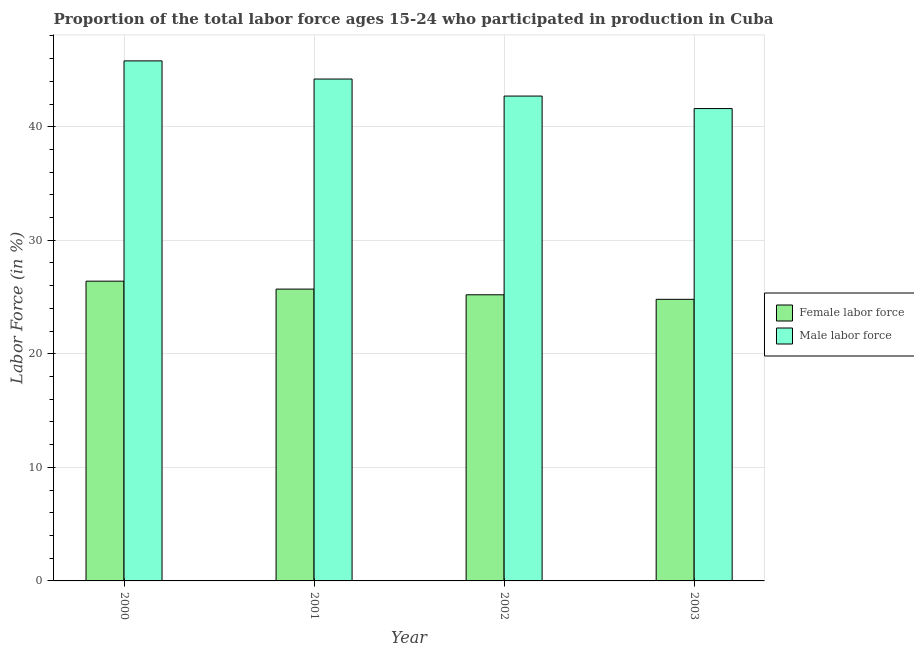How many groups of bars are there?
Keep it short and to the point. 4. Are the number of bars on each tick of the X-axis equal?
Your answer should be very brief. Yes. How many bars are there on the 3rd tick from the left?
Offer a very short reply. 2. How many bars are there on the 4th tick from the right?
Your response must be concise. 2. What is the label of the 4th group of bars from the left?
Provide a succinct answer. 2003. What is the percentage of male labour force in 2000?
Offer a terse response. 45.8. Across all years, what is the maximum percentage of male labour force?
Offer a very short reply. 45.8. Across all years, what is the minimum percentage of male labour force?
Your response must be concise. 41.6. In which year was the percentage of female labor force minimum?
Provide a short and direct response. 2003. What is the total percentage of female labor force in the graph?
Keep it short and to the point. 102.1. What is the difference between the percentage of male labour force in 2000 and that in 2003?
Offer a terse response. 4.2. What is the difference between the percentage of female labor force in 2001 and the percentage of male labour force in 2002?
Make the answer very short. 0.5. What is the average percentage of male labour force per year?
Offer a very short reply. 43.57. In the year 2000, what is the difference between the percentage of male labour force and percentage of female labor force?
Your response must be concise. 0. What is the ratio of the percentage of male labour force in 2000 to that in 2002?
Provide a succinct answer. 1.07. Is the difference between the percentage of female labor force in 2001 and 2002 greater than the difference between the percentage of male labour force in 2001 and 2002?
Provide a succinct answer. No. What is the difference between the highest and the second highest percentage of female labor force?
Your answer should be very brief. 0.7. What is the difference between the highest and the lowest percentage of female labor force?
Make the answer very short. 1.6. Is the sum of the percentage of male labour force in 2000 and 2002 greater than the maximum percentage of female labor force across all years?
Your answer should be very brief. Yes. What does the 1st bar from the left in 2003 represents?
Offer a terse response. Female labor force. What does the 2nd bar from the right in 2003 represents?
Your answer should be compact. Female labor force. How many bars are there?
Keep it short and to the point. 8. Are all the bars in the graph horizontal?
Provide a succinct answer. No. How many years are there in the graph?
Your answer should be compact. 4. What is the difference between two consecutive major ticks on the Y-axis?
Ensure brevity in your answer.  10. Does the graph contain any zero values?
Provide a succinct answer. No. Does the graph contain grids?
Ensure brevity in your answer.  Yes. What is the title of the graph?
Your answer should be compact. Proportion of the total labor force ages 15-24 who participated in production in Cuba. Does "International Tourists" appear as one of the legend labels in the graph?
Ensure brevity in your answer.  No. What is the label or title of the X-axis?
Give a very brief answer. Year. What is the label or title of the Y-axis?
Your answer should be compact. Labor Force (in %). What is the Labor Force (in %) in Female labor force in 2000?
Your answer should be compact. 26.4. What is the Labor Force (in %) in Male labor force in 2000?
Provide a short and direct response. 45.8. What is the Labor Force (in %) in Female labor force in 2001?
Make the answer very short. 25.7. What is the Labor Force (in %) in Male labor force in 2001?
Provide a succinct answer. 44.2. What is the Labor Force (in %) of Female labor force in 2002?
Ensure brevity in your answer.  25.2. What is the Labor Force (in %) of Male labor force in 2002?
Offer a terse response. 42.7. What is the Labor Force (in %) in Female labor force in 2003?
Offer a terse response. 24.8. What is the Labor Force (in %) of Male labor force in 2003?
Offer a very short reply. 41.6. Across all years, what is the maximum Labor Force (in %) of Female labor force?
Your answer should be compact. 26.4. Across all years, what is the maximum Labor Force (in %) of Male labor force?
Keep it short and to the point. 45.8. Across all years, what is the minimum Labor Force (in %) in Female labor force?
Keep it short and to the point. 24.8. Across all years, what is the minimum Labor Force (in %) in Male labor force?
Keep it short and to the point. 41.6. What is the total Labor Force (in %) in Female labor force in the graph?
Provide a short and direct response. 102.1. What is the total Labor Force (in %) of Male labor force in the graph?
Offer a terse response. 174.3. What is the difference between the Labor Force (in %) of Female labor force in 2000 and that in 2002?
Keep it short and to the point. 1.2. What is the difference between the Labor Force (in %) in Female labor force in 2000 and that in 2003?
Provide a short and direct response. 1.6. What is the difference between the Labor Force (in %) of Female labor force in 2001 and that in 2003?
Your answer should be very brief. 0.9. What is the difference between the Labor Force (in %) in Female labor force in 2000 and the Labor Force (in %) in Male labor force in 2001?
Keep it short and to the point. -17.8. What is the difference between the Labor Force (in %) of Female labor force in 2000 and the Labor Force (in %) of Male labor force in 2002?
Make the answer very short. -16.3. What is the difference between the Labor Force (in %) in Female labor force in 2000 and the Labor Force (in %) in Male labor force in 2003?
Keep it short and to the point. -15.2. What is the difference between the Labor Force (in %) of Female labor force in 2001 and the Labor Force (in %) of Male labor force in 2002?
Ensure brevity in your answer.  -17. What is the difference between the Labor Force (in %) in Female labor force in 2001 and the Labor Force (in %) in Male labor force in 2003?
Your answer should be very brief. -15.9. What is the difference between the Labor Force (in %) of Female labor force in 2002 and the Labor Force (in %) of Male labor force in 2003?
Ensure brevity in your answer.  -16.4. What is the average Labor Force (in %) in Female labor force per year?
Your answer should be compact. 25.52. What is the average Labor Force (in %) of Male labor force per year?
Ensure brevity in your answer.  43.58. In the year 2000, what is the difference between the Labor Force (in %) of Female labor force and Labor Force (in %) of Male labor force?
Offer a very short reply. -19.4. In the year 2001, what is the difference between the Labor Force (in %) in Female labor force and Labor Force (in %) in Male labor force?
Keep it short and to the point. -18.5. In the year 2002, what is the difference between the Labor Force (in %) in Female labor force and Labor Force (in %) in Male labor force?
Offer a very short reply. -17.5. In the year 2003, what is the difference between the Labor Force (in %) of Female labor force and Labor Force (in %) of Male labor force?
Offer a terse response. -16.8. What is the ratio of the Labor Force (in %) of Female labor force in 2000 to that in 2001?
Give a very brief answer. 1.03. What is the ratio of the Labor Force (in %) in Male labor force in 2000 to that in 2001?
Give a very brief answer. 1.04. What is the ratio of the Labor Force (in %) in Female labor force in 2000 to that in 2002?
Your response must be concise. 1.05. What is the ratio of the Labor Force (in %) in Male labor force in 2000 to that in 2002?
Provide a short and direct response. 1.07. What is the ratio of the Labor Force (in %) in Female labor force in 2000 to that in 2003?
Provide a succinct answer. 1.06. What is the ratio of the Labor Force (in %) of Male labor force in 2000 to that in 2003?
Offer a very short reply. 1.1. What is the ratio of the Labor Force (in %) of Female labor force in 2001 to that in 2002?
Your answer should be compact. 1.02. What is the ratio of the Labor Force (in %) of Male labor force in 2001 to that in 2002?
Your answer should be compact. 1.04. What is the ratio of the Labor Force (in %) of Female labor force in 2001 to that in 2003?
Provide a succinct answer. 1.04. What is the ratio of the Labor Force (in %) in Male labor force in 2001 to that in 2003?
Offer a terse response. 1.06. What is the ratio of the Labor Force (in %) in Female labor force in 2002 to that in 2003?
Keep it short and to the point. 1.02. What is the ratio of the Labor Force (in %) of Male labor force in 2002 to that in 2003?
Your answer should be very brief. 1.03. What is the difference between the highest and the second highest Labor Force (in %) of Female labor force?
Make the answer very short. 0.7. What is the difference between the highest and the second highest Labor Force (in %) in Male labor force?
Your response must be concise. 1.6. 